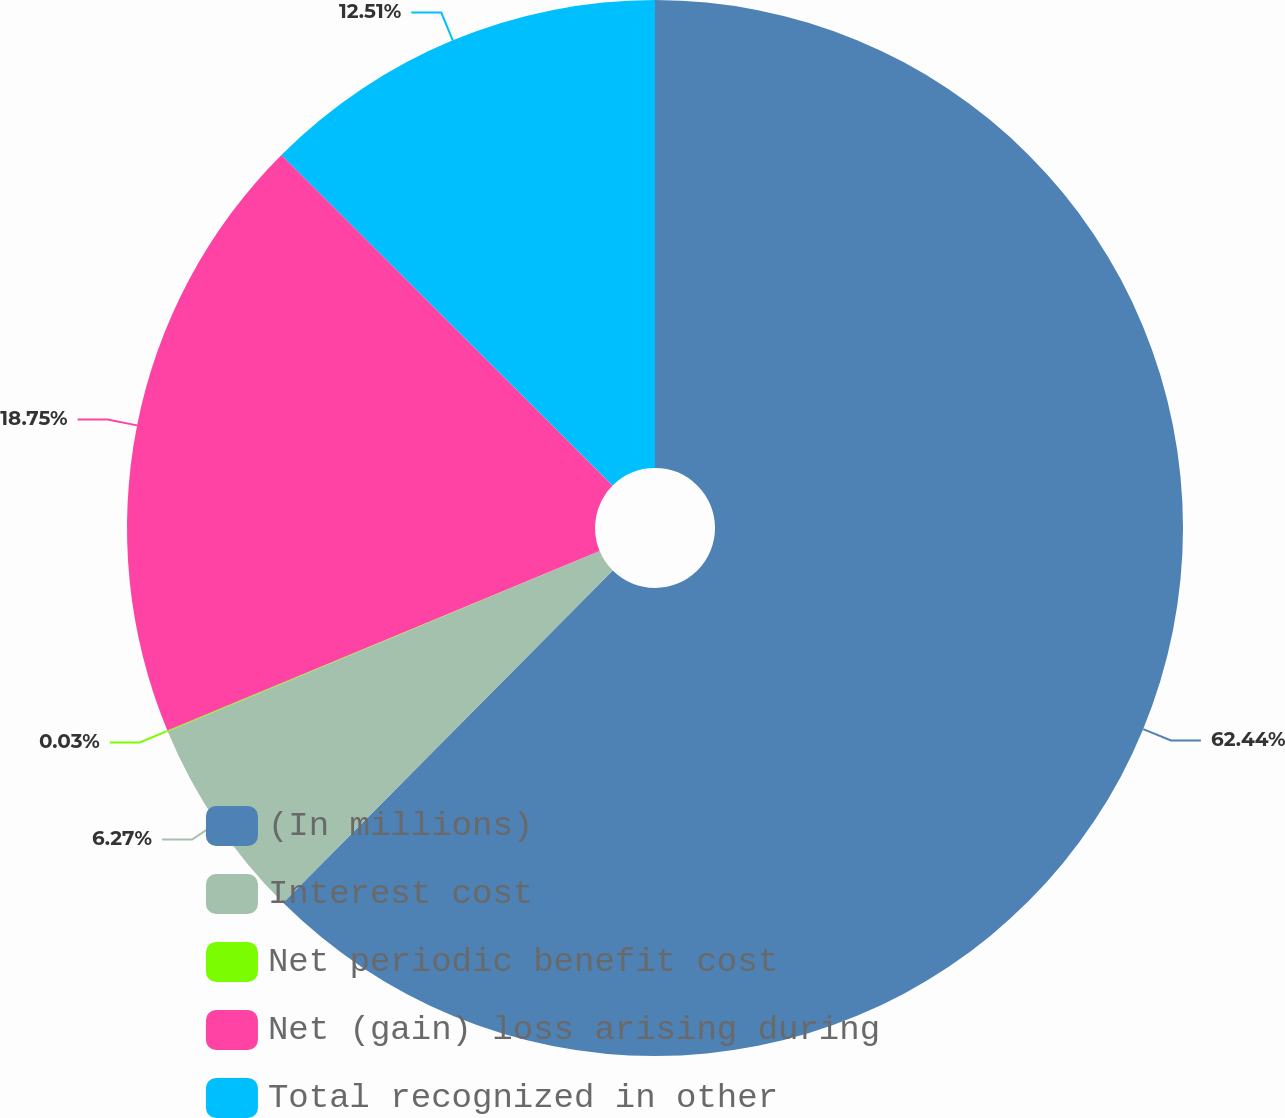Convert chart. <chart><loc_0><loc_0><loc_500><loc_500><pie_chart><fcel>(In millions)<fcel>Interest cost<fcel>Net periodic benefit cost<fcel>Net (gain) loss arising during<fcel>Total recognized in other<nl><fcel>62.43%<fcel>6.27%<fcel>0.03%<fcel>18.75%<fcel>12.51%<nl></chart> 